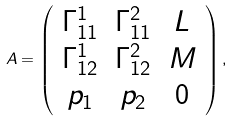<formula> <loc_0><loc_0><loc_500><loc_500>A = \left ( \begin{array} { c c c } \Gamma ^ { 1 } _ { 1 1 } & \Gamma ^ { 2 } _ { 1 1 } & L \\ \Gamma ^ { 1 } _ { 1 2 } & \Gamma ^ { 2 } _ { 1 2 } & M \\ p _ { 1 } & p _ { 2 } & 0 \end{array} \right ) ,</formula> 